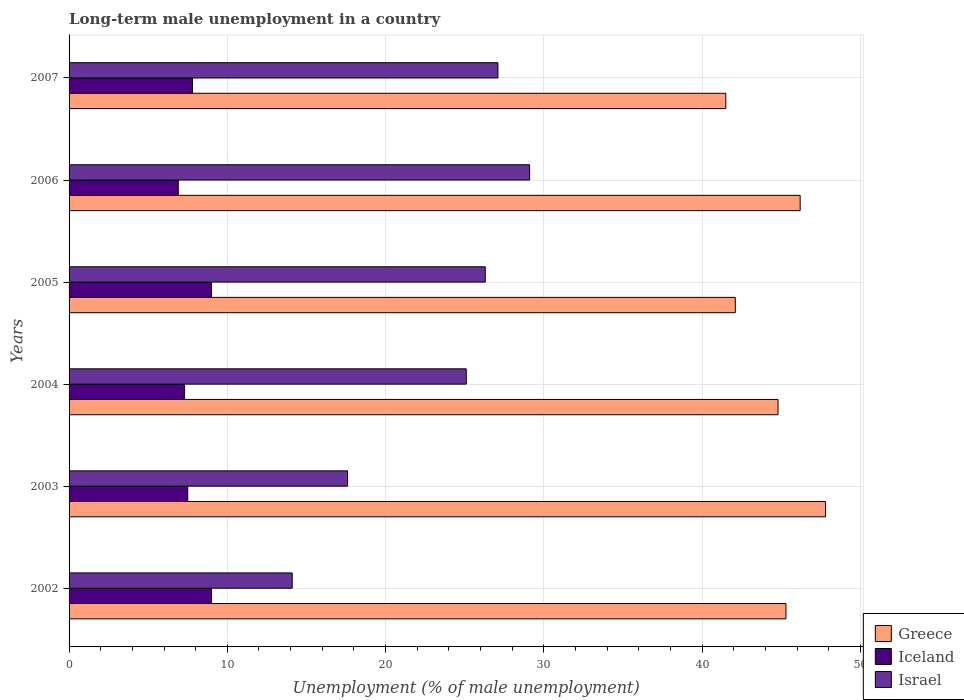How many groups of bars are there?
Your answer should be very brief. 6. Are the number of bars on each tick of the Y-axis equal?
Your answer should be very brief. Yes. How many bars are there on the 2nd tick from the bottom?
Make the answer very short. 3. In how many cases, is the number of bars for a given year not equal to the number of legend labels?
Provide a short and direct response. 0. What is the percentage of long-term unemployed male population in Iceland in 2004?
Your answer should be compact. 7.3. Across all years, what is the maximum percentage of long-term unemployed male population in Israel?
Offer a very short reply. 29.1. Across all years, what is the minimum percentage of long-term unemployed male population in Greece?
Your answer should be very brief. 41.5. What is the total percentage of long-term unemployed male population in Iceland in the graph?
Make the answer very short. 47.5. What is the difference between the percentage of long-term unemployed male population in Israel in 2005 and that in 2007?
Your answer should be very brief. -0.8. What is the difference between the percentage of long-term unemployed male population in Iceland in 2004 and the percentage of long-term unemployed male population in Israel in 2005?
Your answer should be very brief. -19. What is the average percentage of long-term unemployed male population in Iceland per year?
Provide a short and direct response. 7.92. In the year 2004, what is the difference between the percentage of long-term unemployed male population in Greece and percentage of long-term unemployed male population in Israel?
Offer a very short reply. 19.7. In how many years, is the percentage of long-term unemployed male population in Iceland greater than 20 %?
Your answer should be very brief. 0. What is the ratio of the percentage of long-term unemployed male population in Israel in 2002 to that in 2003?
Your response must be concise. 0.8. Is the percentage of long-term unemployed male population in Iceland in 2002 less than that in 2007?
Make the answer very short. No. Is the difference between the percentage of long-term unemployed male population in Greece in 2005 and 2007 greater than the difference between the percentage of long-term unemployed male population in Israel in 2005 and 2007?
Your answer should be compact. Yes. What is the difference between the highest and the second highest percentage of long-term unemployed male population in Iceland?
Your answer should be very brief. 0. What is the difference between the highest and the lowest percentage of long-term unemployed male population in Iceland?
Keep it short and to the point. 2.1. In how many years, is the percentage of long-term unemployed male population in Israel greater than the average percentage of long-term unemployed male population in Israel taken over all years?
Your response must be concise. 4. Is the sum of the percentage of long-term unemployed male population in Greece in 2004 and 2006 greater than the maximum percentage of long-term unemployed male population in Iceland across all years?
Provide a short and direct response. Yes. What does the 3rd bar from the bottom in 2006 represents?
Offer a very short reply. Israel. How many bars are there?
Offer a terse response. 18. Are all the bars in the graph horizontal?
Provide a short and direct response. Yes. What is the difference between two consecutive major ticks on the X-axis?
Offer a very short reply. 10. Does the graph contain any zero values?
Give a very brief answer. No. Where does the legend appear in the graph?
Your answer should be compact. Bottom right. How many legend labels are there?
Ensure brevity in your answer.  3. How are the legend labels stacked?
Give a very brief answer. Vertical. What is the title of the graph?
Make the answer very short. Long-term male unemployment in a country. Does "Thailand" appear as one of the legend labels in the graph?
Offer a very short reply. No. What is the label or title of the X-axis?
Your answer should be compact. Unemployment (% of male unemployment). What is the label or title of the Y-axis?
Your answer should be very brief. Years. What is the Unemployment (% of male unemployment) of Greece in 2002?
Your answer should be very brief. 45.3. What is the Unemployment (% of male unemployment) of Iceland in 2002?
Your answer should be very brief. 9. What is the Unemployment (% of male unemployment) in Israel in 2002?
Provide a succinct answer. 14.1. What is the Unemployment (% of male unemployment) of Greece in 2003?
Provide a short and direct response. 47.8. What is the Unemployment (% of male unemployment) of Israel in 2003?
Offer a very short reply. 17.6. What is the Unemployment (% of male unemployment) in Greece in 2004?
Give a very brief answer. 44.8. What is the Unemployment (% of male unemployment) in Iceland in 2004?
Provide a short and direct response. 7.3. What is the Unemployment (% of male unemployment) in Israel in 2004?
Keep it short and to the point. 25.1. What is the Unemployment (% of male unemployment) of Greece in 2005?
Keep it short and to the point. 42.1. What is the Unemployment (% of male unemployment) in Iceland in 2005?
Keep it short and to the point. 9. What is the Unemployment (% of male unemployment) in Israel in 2005?
Your answer should be very brief. 26.3. What is the Unemployment (% of male unemployment) in Greece in 2006?
Provide a succinct answer. 46.2. What is the Unemployment (% of male unemployment) in Iceland in 2006?
Your response must be concise. 6.9. What is the Unemployment (% of male unemployment) of Israel in 2006?
Make the answer very short. 29.1. What is the Unemployment (% of male unemployment) in Greece in 2007?
Offer a terse response. 41.5. What is the Unemployment (% of male unemployment) of Iceland in 2007?
Offer a terse response. 7.8. What is the Unemployment (% of male unemployment) in Israel in 2007?
Your answer should be compact. 27.1. Across all years, what is the maximum Unemployment (% of male unemployment) of Greece?
Offer a very short reply. 47.8. Across all years, what is the maximum Unemployment (% of male unemployment) in Iceland?
Ensure brevity in your answer.  9. Across all years, what is the maximum Unemployment (% of male unemployment) in Israel?
Offer a very short reply. 29.1. Across all years, what is the minimum Unemployment (% of male unemployment) of Greece?
Make the answer very short. 41.5. Across all years, what is the minimum Unemployment (% of male unemployment) in Iceland?
Ensure brevity in your answer.  6.9. Across all years, what is the minimum Unemployment (% of male unemployment) of Israel?
Give a very brief answer. 14.1. What is the total Unemployment (% of male unemployment) of Greece in the graph?
Give a very brief answer. 267.7. What is the total Unemployment (% of male unemployment) in Iceland in the graph?
Keep it short and to the point. 47.5. What is the total Unemployment (% of male unemployment) in Israel in the graph?
Provide a succinct answer. 139.3. What is the difference between the Unemployment (% of male unemployment) in Israel in 2002 and that in 2003?
Keep it short and to the point. -3.5. What is the difference between the Unemployment (% of male unemployment) in Greece in 2002 and that in 2004?
Provide a short and direct response. 0.5. What is the difference between the Unemployment (% of male unemployment) in Iceland in 2002 and that in 2004?
Give a very brief answer. 1.7. What is the difference between the Unemployment (% of male unemployment) of Israel in 2002 and that in 2004?
Your answer should be compact. -11. What is the difference between the Unemployment (% of male unemployment) of Iceland in 2002 and that in 2005?
Provide a short and direct response. 0. What is the difference between the Unemployment (% of male unemployment) of Israel in 2002 and that in 2006?
Make the answer very short. -15. What is the difference between the Unemployment (% of male unemployment) in Greece in 2002 and that in 2007?
Keep it short and to the point. 3.8. What is the difference between the Unemployment (% of male unemployment) in Israel in 2002 and that in 2007?
Your answer should be compact. -13. What is the difference between the Unemployment (% of male unemployment) of Greece in 2003 and that in 2005?
Your answer should be compact. 5.7. What is the difference between the Unemployment (% of male unemployment) of Iceland in 2003 and that in 2005?
Offer a terse response. -1.5. What is the difference between the Unemployment (% of male unemployment) of Israel in 2003 and that in 2005?
Your answer should be very brief. -8.7. What is the difference between the Unemployment (% of male unemployment) of Iceland in 2003 and that in 2006?
Ensure brevity in your answer.  0.6. What is the difference between the Unemployment (% of male unemployment) in Israel in 2003 and that in 2006?
Your answer should be compact. -11.5. What is the difference between the Unemployment (% of male unemployment) in Israel in 2003 and that in 2007?
Offer a very short reply. -9.5. What is the difference between the Unemployment (% of male unemployment) of Israel in 2004 and that in 2005?
Your response must be concise. -1.2. What is the difference between the Unemployment (% of male unemployment) of Iceland in 2004 and that in 2006?
Offer a terse response. 0.4. What is the difference between the Unemployment (% of male unemployment) of Israel in 2004 and that in 2006?
Provide a short and direct response. -4. What is the difference between the Unemployment (% of male unemployment) in Iceland in 2004 and that in 2007?
Your answer should be compact. -0.5. What is the difference between the Unemployment (% of male unemployment) of Greece in 2005 and that in 2006?
Your answer should be compact. -4.1. What is the difference between the Unemployment (% of male unemployment) in Iceland in 2005 and that in 2006?
Your answer should be compact. 2.1. What is the difference between the Unemployment (% of male unemployment) in Israel in 2005 and that in 2006?
Your response must be concise. -2.8. What is the difference between the Unemployment (% of male unemployment) in Greece in 2005 and that in 2007?
Your answer should be compact. 0.6. What is the difference between the Unemployment (% of male unemployment) of Iceland in 2005 and that in 2007?
Offer a terse response. 1.2. What is the difference between the Unemployment (% of male unemployment) in Greece in 2006 and that in 2007?
Give a very brief answer. 4.7. What is the difference between the Unemployment (% of male unemployment) in Iceland in 2006 and that in 2007?
Offer a very short reply. -0.9. What is the difference between the Unemployment (% of male unemployment) in Greece in 2002 and the Unemployment (% of male unemployment) in Iceland in 2003?
Your answer should be compact. 37.8. What is the difference between the Unemployment (% of male unemployment) of Greece in 2002 and the Unemployment (% of male unemployment) of Israel in 2003?
Provide a short and direct response. 27.7. What is the difference between the Unemployment (% of male unemployment) in Iceland in 2002 and the Unemployment (% of male unemployment) in Israel in 2003?
Ensure brevity in your answer.  -8.6. What is the difference between the Unemployment (% of male unemployment) in Greece in 2002 and the Unemployment (% of male unemployment) in Israel in 2004?
Your answer should be compact. 20.2. What is the difference between the Unemployment (% of male unemployment) of Iceland in 2002 and the Unemployment (% of male unemployment) of Israel in 2004?
Make the answer very short. -16.1. What is the difference between the Unemployment (% of male unemployment) in Greece in 2002 and the Unemployment (% of male unemployment) in Iceland in 2005?
Your answer should be compact. 36.3. What is the difference between the Unemployment (% of male unemployment) of Iceland in 2002 and the Unemployment (% of male unemployment) of Israel in 2005?
Ensure brevity in your answer.  -17.3. What is the difference between the Unemployment (% of male unemployment) of Greece in 2002 and the Unemployment (% of male unemployment) of Iceland in 2006?
Offer a very short reply. 38.4. What is the difference between the Unemployment (% of male unemployment) in Greece in 2002 and the Unemployment (% of male unemployment) in Israel in 2006?
Offer a very short reply. 16.2. What is the difference between the Unemployment (% of male unemployment) in Iceland in 2002 and the Unemployment (% of male unemployment) in Israel in 2006?
Your response must be concise. -20.1. What is the difference between the Unemployment (% of male unemployment) in Greece in 2002 and the Unemployment (% of male unemployment) in Iceland in 2007?
Keep it short and to the point. 37.5. What is the difference between the Unemployment (% of male unemployment) in Iceland in 2002 and the Unemployment (% of male unemployment) in Israel in 2007?
Keep it short and to the point. -18.1. What is the difference between the Unemployment (% of male unemployment) of Greece in 2003 and the Unemployment (% of male unemployment) of Iceland in 2004?
Provide a succinct answer. 40.5. What is the difference between the Unemployment (% of male unemployment) of Greece in 2003 and the Unemployment (% of male unemployment) of Israel in 2004?
Provide a succinct answer. 22.7. What is the difference between the Unemployment (% of male unemployment) in Iceland in 2003 and the Unemployment (% of male unemployment) in Israel in 2004?
Make the answer very short. -17.6. What is the difference between the Unemployment (% of male unemployment) of Greece in 2003 and the Unemployment (% of male unemployment) of Iceland in 2005?
Ensure brevity in your answer.  38.8. What is the difference between the Unemployment (% of male unemployment) of Iceland in 2003 and the Unemployment (% of male unemployment) of Israel in 2005?
Provide a short and direct response. -18.8. What is the difference between the Unemployment (% of male unemployment) in Greece in 2003 and the Unemployment (% of male unemployment) in Iceland in 2006?
Make the answer very short. 40.9. What is the difference between the Unemployment (% of male unemployment) of Greece in 2003 and the Unemployment (% of male unemployment) of Israel in 2006?
Give a very brief answer. 18.7. What is the difference between the Unemployment (% of male unemployment) of Iceland in 2003 and the Unemployment (% of male unemployment) of Israel in 2006?
Keep it short and to the point. -21.6. What is the difference between the Unemployment (% of male unemployment) of Greece in 2003 and the Unemployment (% of male unemployment) of Israel in 2007?
Give a very brief answer. 20.7. What is the difference between the Unemployment (% of male unemployment) in Iceland in 2003 and the Unemployment (% of male unemployment) in Israel in 2007?
Provide a succinct answer. -19.6. What is the difference between the Unemployment (% of male unemployment) in Greece in 2004 and the Unemployment (% of male unemployment) in Iceland in 2005?
Your answer should be compact. 35.8. What is the difference between the Unemployment (% of male unemployment) in Iceland in 2004 and the Unemployment (% of male unemployment) in Israel in 2005?
Offer a terse response. -19. What is the difference between the Unemployment (% of male unemployment) of Greece in 2004 and the Unemployment (% of male unemployment) of Iceland in 2006?
Provide a succinct answer. 37.9. What is the difference between the Unemployment (% of male unemployment) in Iceland in 2004 and the Unemployment (% of male unemployment) in Israel in 2006?
Provide a succinct answer. -21.8. What is the difference between the Unemployment (% of male unemployment) of Iceland in 2004 and the Unemployment (% of male unemployment) of Israel in 2007?
Your response must be concise. -19.8. What is the difference between the Unemployment (% of male unemployment) in Greece in 2005 and the Unemployment (% of male unemployment) in Iceland in 2006?
Offer a terse response. 35.2. What is the difference between the Unemployment (% of male unemployment) of Greece in 2005 and the Unemployment (% of male unemployment) of Israel in 2006?
Offer a very short reply. 13. What is the difference between the Unemployment (% of male unemployment) in Iceland in 2005 and the Unemployment (% of male unemployment) in Israel in 2006?
Give a very brief answer. -20.1. What is the difference between the Unemployment (% of male unemployment) in Greece in 2005 and the Unemployment (% of male unemployment) in Iceland in 2007?
Provide a succinct answer. 34.3. What is the difference between the Unemployment (% of male unemployment) in Greece in 2005 and the Unemployment (% of male unemployment) in Israel in 2007?
Provide a short and direct response. 15. What is the difference between the Unemployment (% of male unemployment) of Iceland in 2005 and the Unemployment (% of male unemployment) of Israel in 2007?
Your response must be concise. -18.1. What is the difference between the Unemployment (% of male unemployment) of Greece in 2006 and the Unemployment (% of male unemployment) of Iceland in 2007?
Offer a very short reply. 38.4. What is the difference between the Unemployment (% of male unemployment) of Iceland in 2006 and the Unemployment (% of male unemployment) of Israel in 2007?
Your answer should be very brief. -20.2. What is the average Unemployment (% of male unemployment) in Greece per year?
Keep it short and to the point. 44.62. What is the average Unemployment (% of male unemployment) in Iceland per year?
Offer a terse response. 7.92. What is the average Unemployment (% of male unemployment) of Israel per year?
Ensure brevity in your answer.  23.22. In the year 2002, what is the difference between the Unemployment (% of male unemployment) of Greece and Unemployment (% of male unemployment) of Iceland?
Ensure brevity in your answer.  36.3. In the year 2002, what is the difference between the Unemployment (% of male unemployment) in Greece and Unemployment (% of male unemployment) in Israel?
Offer a terse response. 31.2. In the year 2002, what is the difference between the Unemployment (% of male unemployment) of Iceland and Unemployment (% of male unemployment) of Israel?
Offer a terse response. -5.1. In the year 2003, what is the difference between the Unemployment (% of male unemployment) of Greece and Unemployment (% of male unemployment) of Iceland?
Provide a short and direct response. 40.3. In the year 2003, what is the difference between the Unemployment (% of male unemployment) of Greece and Unemployment (% of male unemployment) of Israel?
Your answer should be very brief. 30.2. In the year 2003, what is the difference between the Unemployment (% of male unemployment) of Iceland and Unemployment (% of male unemployment) of Israel?
Keep it short and to the point. -10.1. In the year 2004, what is the difference between the Unemployment (% of male unemployment) of Greece and Unemployment (% of male unemployment) of Iceland?
Offer a terse response. 37.5. In the year 2004, what is the difference between the Unemployment (% of male unemployment) of Greece and Unemployment (% of male unemployment) of Israel?
Offer a very short reply. 19.7. In the year 2004, what is the difference between the Unemployment (% of male unemployment) of Iceland and Unemployment (% of male unemployment) of Israel?
Offer a terse response. -17.8. In the year 2005, what is the difference between the Unemployment (% of male unemployment) of Greece and Unemployment (% of male unemployment) of Iceland?
Keep it short and to the point. 33.1. In the year 2005, what is the difference between the Unemployment (% of male unemployment) of Iceland and Unemployment (% of male unemployment) of Israel?
Provide a succinct answer. -17.3. In the year 2006, what is the difference between the Unemployment (% of male unemployment) in Greece and Unemployment (% of male unemployment) in Iceland?
Keep it short and to the point. 39.3. In the year 2006, what is the difference between the Unemployment (% of male unemployment) in Iceland and Unemployment (% of male unemployment) in Israel?
Provide a succinct answer. -22.2. In the year 2007, what is the difference between the Unemployment (% of male unemployment) of Greece and Unemployment (% of male unemployment) of Iceland?
Your response must be concise. 33.7. In the year 2007, what is the difference between the Unemployment (% of male unemployment) in Greece and Unemployment (% of male unemployment) in Israel?
Offer a terse response. 14.4. In the year 2007, what is the difference between the Unemployment (% of male unemployment) of Iceland and Unemployment (% of male unemployment) of Israel?
Offer a very short reply. -19.3. What is the ratio of the Unemployment (% of male unemployment) of Greece in 2002 to that in 2003?
Your answer should be very brief. 0.95. What is the ratio of the Unemployment (% of male unemployment) in Israel in 2002 to that in 2003?
Offer a terse response. 0.8. What is the ratio of the Unemployment (% of male unemployment) of Greece in 2002 to that in 2004?
Your answer should be very brief. 1.01. What is the ratio of the Unemployment (% of male unemployment) in Iceland in 2002 to that in 2004?
Your answer should be very brief. 1.23. What is the ratio of the Unemployment (% of male unemployment) in Israel in 2002 to that in 2004?
Your response must be concise. 0.56. What is the ratio of the Unemployment (% of male unemployment) in Greece in 2002 to that in 2005?
Offer a terse response. 1.08. What is the ratio of the Unemployment (% of male unemployment) in Iceland in 2002 to that in 2005?
Your response must be concise. 1. What is the ratio of the Unemployment (% of male unemployment) of Israel in 2002 to that in 2005?
Provide a short and direct response. 0.54. What is the ratio of the Unemployment (% of male unemployment) in Greece in 2002 to that in 2006?
Ensure brevity in your answer.  0.98. What is the ratio of the Unemployment (% of male unemployment) of Iceland in 2002 to that in 2006?
Provide a short and direct response. 1.3. What is the ratio of the Unemployment (% of male unemployment) of Israel in 2002 to that in 2006?
Provide a short and direct response. 0.48. What is the ratio of the Unemployment (% of male unemployment) of Greece in 2002 to that in 2007?
Provide a succinct answer. 1.09. What is the ratio of the Unemployment (% of male unemployment) in Iceland in 2002 to that in 2007?
Offer a terse response. 1.15. What is the ratio of the Unemployment (% of male unemployment) in Israel in 2002 to that in 2007?
Your response must be concise. 0.52. What is the ratio of the Unemployment (% of male unemployment) of Greece in 2003 to that in 2004?
Offer a terse response. 1.07. What is the ratio of the Unemployment (% of male unemployment) of Iceland in 2003 to that in 2004?
Give a very brief answer. 1.03. What is the ratio of the Unemployment (% of male unemployment) of Israel in 2003 to that in 2004?
Provide a short and direct response. 0.7. What is the ratio of the Unemployment (% of male unemployment) in Greece in 2003 to that in 2005?
Give a very brief answer. 1.14. What is the ratio of the Unemployment (% of male unemployment) of Israel in 2003 to that in 2005?
Give a very brief answer. 0.67. What is the ratio of the Unemployment (% of male unemployment) in Greece in 2003 to that in 2006?
Give a very brief answer. 1.03. What is the ratio of the Unemployment (% of male unemployment) of Iceland in 2003 to that in 2006?
Offer a very short reply. 1.09. What is the ratio of the Unemployment (% of male unemployment) in Israel in 2003 to that in 2006?
Offer a very short reply. 0.6. What is the ratio of the Unemployment (% of male unemployment) of Greece in 2003 to that in 2007?
Make the answer very short. 1.15. What is the ratio of the Unemployment (% of male unemployment) in Iceland in 2003 to that in 2007?
Your response must be concise. 0.96. What is the ratio of the Unemployment (% of male unemployment) of Israel in 2003 to that in 2007?
Your answer should be very brief. 0.65. What is the ratio of the Unemployment (% of male unemployment) of Greece in 2004 to that in 2005?
Provide a succinct answer. 1.06. What is the ratio of the Unemployment (% of male unemployment) in Iceland in 2004 to that in 2005?
Provide a short and direct response. 0.81. What is the ratio of the Unemployment (% of male unemployment) of Israel in 2004 to that in 2005?
Your response must be concise. 0.95. What is the ratio of the Unemployment (% of male unemployment) of Greece in 2004 to that in 2006?
Make the answer very short. 0.97. What is the ratio of the Unemployment (% of male unemployment) in Iceland in 2004 to that in 2006?
Your answer should be very brief. 1.06. What is the ratio of the Unemployment (% of male unemployment) in Israel in 2004 to that in 2006?
Offer a terse response. 0.86. What is the ratio of the Unemployment (% of male unemployment) in Greece in 2004 to that in 2007?
Provide a short and direct response. 1.08. What is the ratio of the Unemployment (% of male unemployment) of Iceland in 2004 to that in 2007?
Offer a terse response. 0.94. What is the ratio of the Unemployment (% of male unemployment) in Israel in 2004 to that in 2007?
Your answer should be very brief. 0.93. What is the ratio of the Unemployment (% of male unemployment) in Greece in 2005 to that in 2006?
Keep it short and to the point. 0.91. What is the ratio of the Unemployment (% of male unemployment) in Iceland in 2005 to that in 2006?
Ensure brevity in your answer.  1.3. What is the ratio of the Unemployment (% of male unemployment) in Israel in 2005 to that in 2006?
Give a very brief answer. 0.9. What is the ratio of the Unemployment (% of male unemployment) in Greece in 2005 to that in 2007?
Ensure brevity in your answer.  1.01. What is the ratio of the Unemployment (% of male unemployment) of Iceland in 2005 to that in 2007?
Offer a terse response. 1.15. What is the ratio of the Unemployment (% of male unemployment) of Israel in 2005 to that in 2007?
Ensure brevity in your answer.  0.97. What is the ratio of the Unemployment (% of male unemployment) in Greece in 2006 to that in 2007?
Provide a short and direct response. 1.11. What is the ratio of the Unemployment (% of male unemployment) in Iceland in 2006 to that in 2007?
Your response must be concise. 0.88. What is the ratio of the Unemployment (% of male unemployment) of Israel in 2006 to that in 2007?
Your response must be concise. 1.07. What is the difference between the highest and the second highest Unemployment (% of male unemployment) of Israel?
Offer a terse response. 2. What is the difference between the highest and the lowest Unemployment (% of male unemployment) in Greece?
Your answer should be compact. 6.3. What is the difference between the highest and the lowest Unemployment (% of male unemployment) of Israel?
Offer a terse response. 15. 